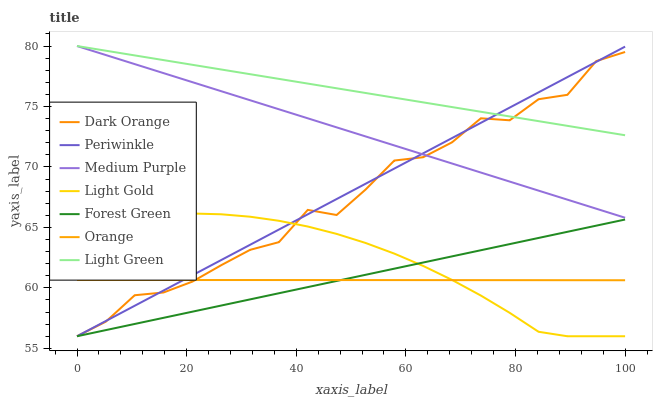Does Orange have the minimum area under the curve?
Answer yes or no. Yes. Does Light Green have the maximum area under the curve?
Answer yes or no. Yes. Does Medium Purple have the minimum area under the curve?
Answer yes or no. No. Does Medium Purple have the maximum area under the curve?
Answer yes or no. No. Is Periwinkle the smoothest?
Answer yes or no. Yes. Is Dark Orange the roughest?
Answer yes or no. Yes. Is Medium Purple the smoothest?
Answer yes or no. No. Is Medium Purple the roughest?
Answer yes or no. No. Does Medium Purple have the lowest value?
Answer yes or no. No. Does Forest Green have the highest value?
Answer yes or no. No. Is Forest Green less than Light Green?
Answer yes or no. Yes. Is Light Green greater than Orange?
Answer yes or no. Yes. Does Forest Green intersect Light Green?
Answer yes or no. No. 